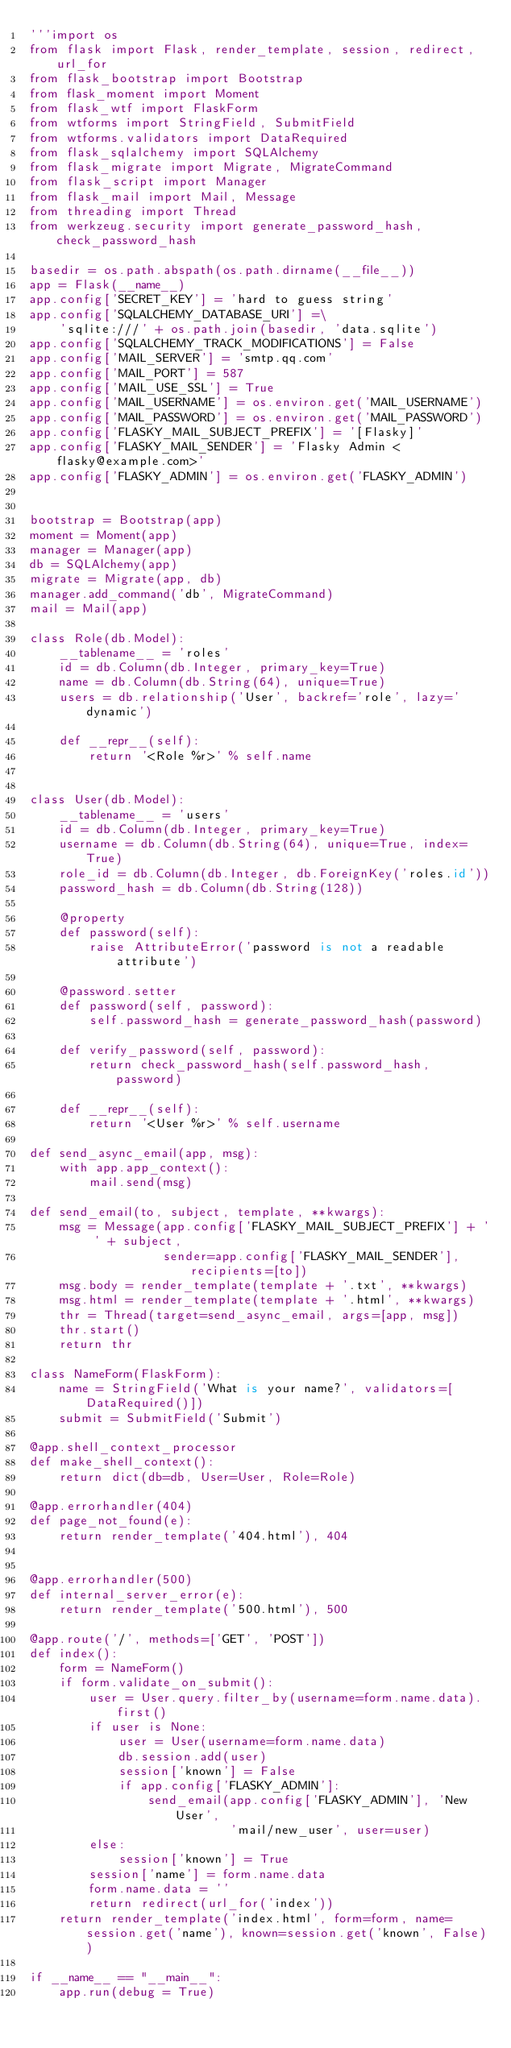<code> <loc_0><loc_0><loc_500><loc_500><_Python_>'''import os
from flask import Flask, render_template, session, redirect, url_for
from flask_bootstrap import Bootstrap
from flask_moment import Moment
from flask_wtf import FlaskForm
from wtforms import StringField, SubmitField
from wtforms.validators import DataRequired
from flask_sqlalchemy import SQLAlchemy
from flask_migrate import Migrate, MigrateCommand
from flask_script import Manager
from flask_mail import Mail, Message
from threading import Thread
from werkzeug.security import generate_password_hash, check_password_hash

basedir = os.path.abspath(os.path.dirname(__file__))
app = Flask(__name__)
app.config['SECRET_KEY'] = 'hard to guess string'
app.config['SQLALCHEMY_DATABASE_URI'] =\
    'sqlite:///' + os.path.join(basedir, 'data.sqlite')
app.config['SQLALCHEMY_TRACK_MODIFICATIONS'] = False
app.config['MAIL_SERVER'] = 'smtp.qq.com'
app.config['MAIL_PORT'] = 587
app.config['MAIL_USE_SSL'] = True
app.config['MAIL_USERNAME'] = os.environ.get('MAIL_USERNAME')
app.config['MAIL_PASSWORD'] = os.environ.get('MAIL_PASSWORD')
app.config['FLASKY_MAIL_SUBJECT_PREFIX'] = '[Flasky]'
app.config['FLASKY_MAIL_SENDER'] = 'Flasky Admin <flasky@example.com>'
app.config['FLASKY_ADMIN'] = os.environ.get('FLASKY_ADMIN')


bootstrap = Bootstrap(app)
moment = Moment(app)
manager = Manager(app)
db = SQLAlchemy(app)
migrate = Migrate(app, db)
manager.add_command('db', MigrateCommand)
mail = Mail(app)

class Role(db.Model):
    __tablename__ = 'roles'
    id = db.Column(db.Integer, primary_key=True)
    name = db.Column(db.String(64), unique=True)
    users = db.relationship('User', backref='role', lazy='dynamic')

    def __repr__(self):
        return '<Role %r>' % self.name


class User(db.Model):
    __tablename__ = 'users'
    id = db.Column(db.Integer, primary_key=True)
    username = db.Column(db.String(64), unique=True, index=True)
    role_id = db.Column(db.Integer, db.ForeignKey('roles.id'))
    password_hash = db.Column(db.String(128))

    @property
    def password(self):
        raise AttributeError('password is not a readable attribute')

    @password.setter
    def password(self, password):
        self.password_hash = generate_password_hash(password)

    def verify_password(self, password):
        return check_password_hash(self.password_hash, password)

    def __repr__(self):
        return '<User %r>' % self.username

def send_async_email(app, msg):
    with app.app_context():
        mail.send(msg)

def send_email(to, subject, template, **kwargs):
    msg = Message(app.config['FLASKY_MAIL_SUBJECT_PREFIX'] + ' ' + subject,
                  sender=app.config['FLASKY_MAIL_SENDER'], recipients=[to])
    msg.body = render_template(template + '.txt', **kwargs)
    msg.html = render_template(template + '.html', **kwargs)
    thr = Thread(target=send_async_email, args=[app, msg])
    thr.start()
    return thr

class NameForm(FlaskForm):
    name = StringField('What is your name?', validators=[DataRequired()])
    submit = SubmitField('Submit')

@app.shell_context_processor
def make_shell_context():
    return dict(db=db, User=User, Role=Role)

@app.errorhandler(404)
def page_not_found(e):
    return render_template('404.html'), 404


@app.errorhandler(500)
def internal_server_error(e):
    return render_template('500.html'), 500

@app.route('/', methods=['GET', 'POST'])
def index():
    form = NameForm()
    if form.validate_on_submit():
        user = User.query.filter_by(username=form.name.data).first()
        if user is None:
            user = User(username=form.name.data)
            db.session.add(user)
            session['known'] = False
            if app.config['FLASKY_ADMIN']:
                send_email(app.config['FLASKY_ADMIN'], 'New User',
                           'mail/new_user', user=user)
        else:
            session['known'] = True
        session['name'] = form.name.data
        form.name.data = ''
        return redirect(url_for('index'))
    return render_template('index.html', form=form, name=session.get('name'), known=session.get('known', False))

if __name__ == "__main__":
    app.run(debug = True)</code> 